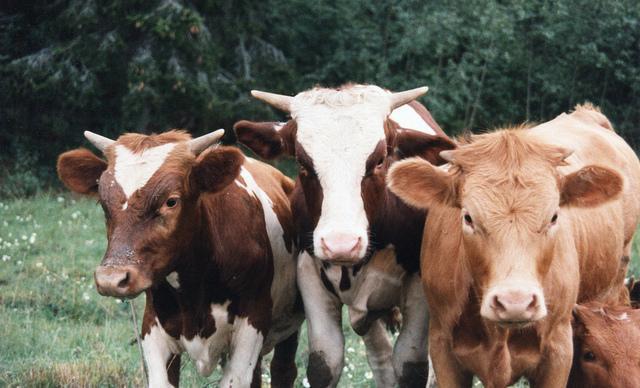How many cows?
Give a very brief answer. 3. How many cows are in the picture?
Give a very brief answer. 4. How many signs are hanging above the toilet that are not written in english?
Give a very brief answer. 0. 